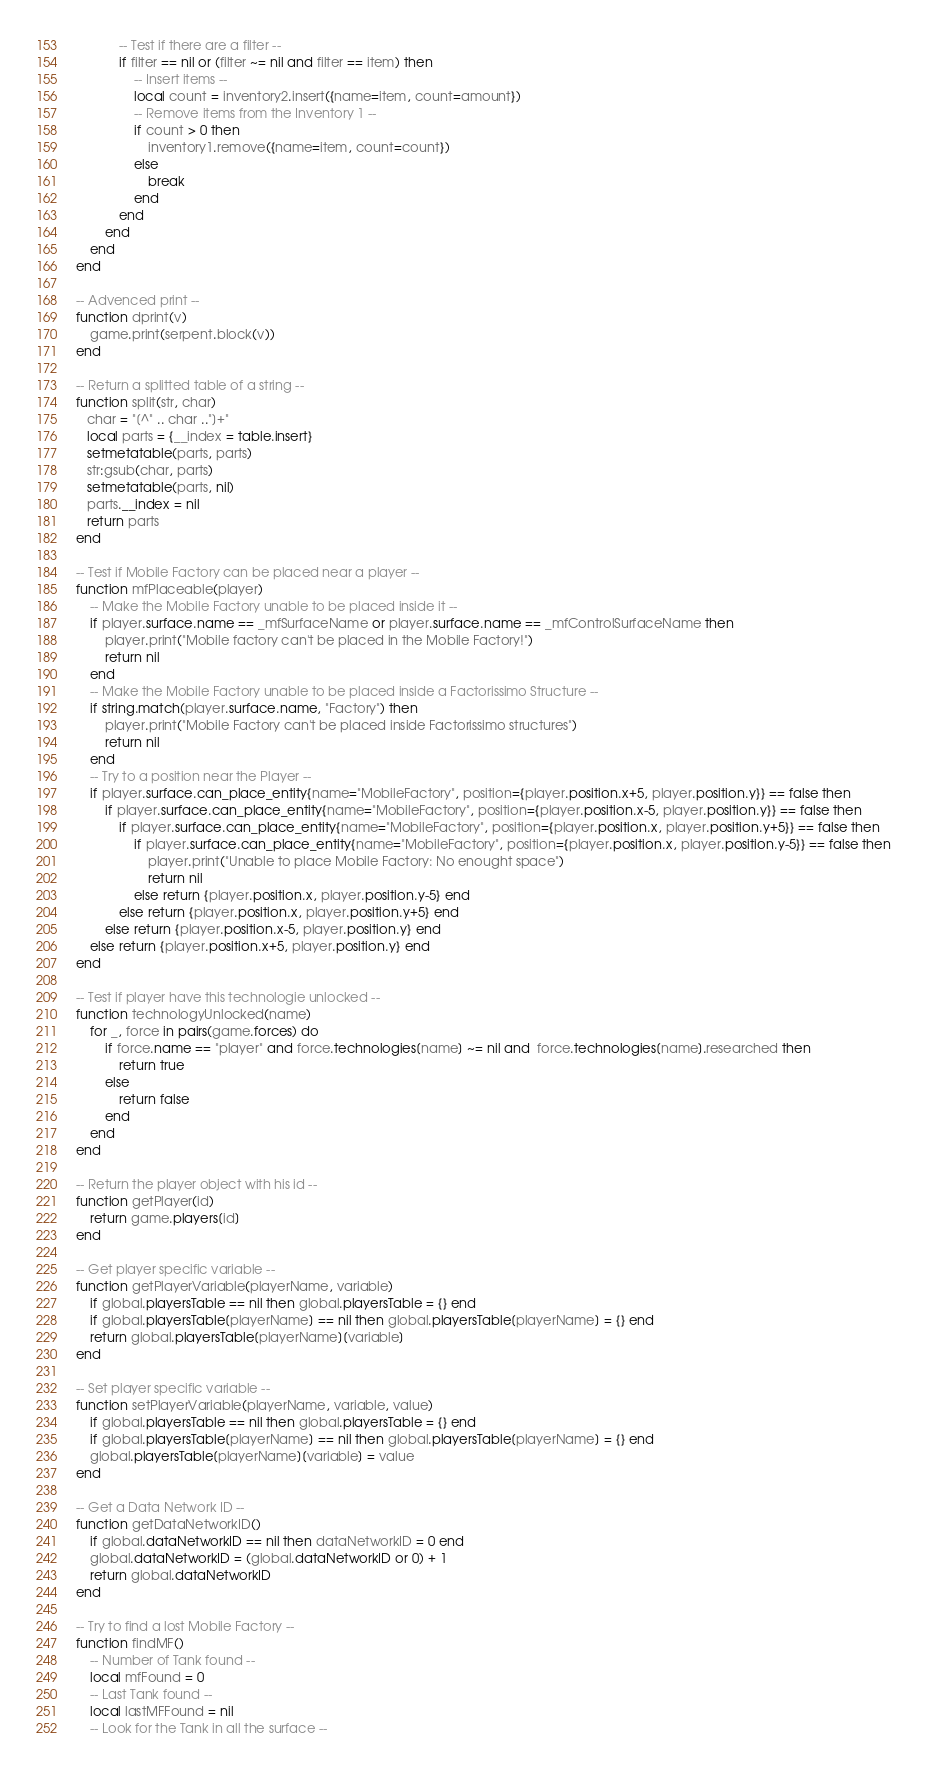<code> <loc_0><loc_0><loc_500><loc_500><_Lua_>			-- Test if there are a filter --
			if filter == nil or (filter ~= nil and filter == item) then 
				-- Insert items --
				local count = inventory2.insert({name=item, count=amount})
				-- Remove items from the Inventory 1 --
				if count > 0 then
					inventory1.remove({name=item, count=count})
				else
					break
				end
			end
		end
	end
end

-- Advenced print --
function dprint(v)
	game.print(serpent.block(v))
end

-- Return a splitted table of a string --
function split(str, char)
   char = "[^" .. char .."]+"
   local parts = {__index = table.insert}
   setmetatable(parts, parts)
   str:gsub(char, parts)
   setmetatable(parts, nil)
   parts.__index = nil
   return parts
end

-- Test if Mobile Factory can be placed near a player --
function mfPlaceable(player)
	-- Make the Mobile Factory unable to be placed inside it --
	if player.surface.name == _mfSurfaceName or player.surface.name == _mfControlSurfaceName then
		player.print("Mobile factory can't be placed in the Mobile Factory!")
		return nil
	end
	-- Make the Mobile Factory unable to be placed inside a Factorissimo Structure --
	if string.match(player.surface.name, "Factory") then
		player.print("Mobile Factory can't be placed inside Factorissimo structures")
		return nil
	end
	-- Try to a position near the Player --
	if player.surface.can_place_entity{name="MobileFactory", position={player.position.x+5, player.position.y}} == false then
		if player.surface.can_place_entity{name="MobileFactory", position={player.position.x-5, player.position.y}} == false then
			if player.surface.can_place_entity{name="MobileFactory", position={player.position.x, player.position.y+5}} == false then
				if player.surface.can_place_entity{name="MobileFactory", position={player.position.x, player.position.y-5}} == false then
					player.print("Unable to place Mobile Factory: No enought space")
					return nil
				else return {player.position.x, player.position.y-5} end
			else return {player.position.x, player.position.y+5} end
		else return {player.position.x-5, player.position.y} end
	else return {player.position.x+5, player.position.y} end
end

-- Test if player have this technologie unlocked --
function technologyUnlocked(name)
	for _, force in pairs(game.forces) do
		if force.name == "player" and force.technologies[name] ~= nil and  force.technologies[name].researched then
			return true
		else
			return false
		end
	end
end

-- Return the player object with his id --
function getPlayer(id)
	return game.players[id]
end

-- Get player specific variable --
function getPlayerVariable(playerName, variable)
	if global.playersTable == nil then global.playersTable = {} end
	if global.playersTable[playerName] == nil then global.playersTable[playerName] = {} end
	return global.playersTable[playerName][variable]
end

-- Set player specific variable --
function setPlayerVariable(playerName, variable, value)
	if global.playersTable == nil then global.playersTable = {} end
	if global.playersTable[playerName] == nil then global.playersTable[playerName] = {} end
	global.playersTable[playerName][variable] = value
end

-- Get a Data Network ID --
function getDataNetworkID()
	if global.dataNetworkID == nil then dataNetworkID = 0 end
	global.dataNetworkID = (global.dataNetworkID or 0) + 1
	return global.dataNetworkID
end

-- Try to find a lost Mobile Factory --
function findMF()
	-- Number of Tank found --
	local mfFound = 0
	-- Last Tank found --
	local lastMFFound = nil
	-- Look for the Tank in all the surface --</code> 